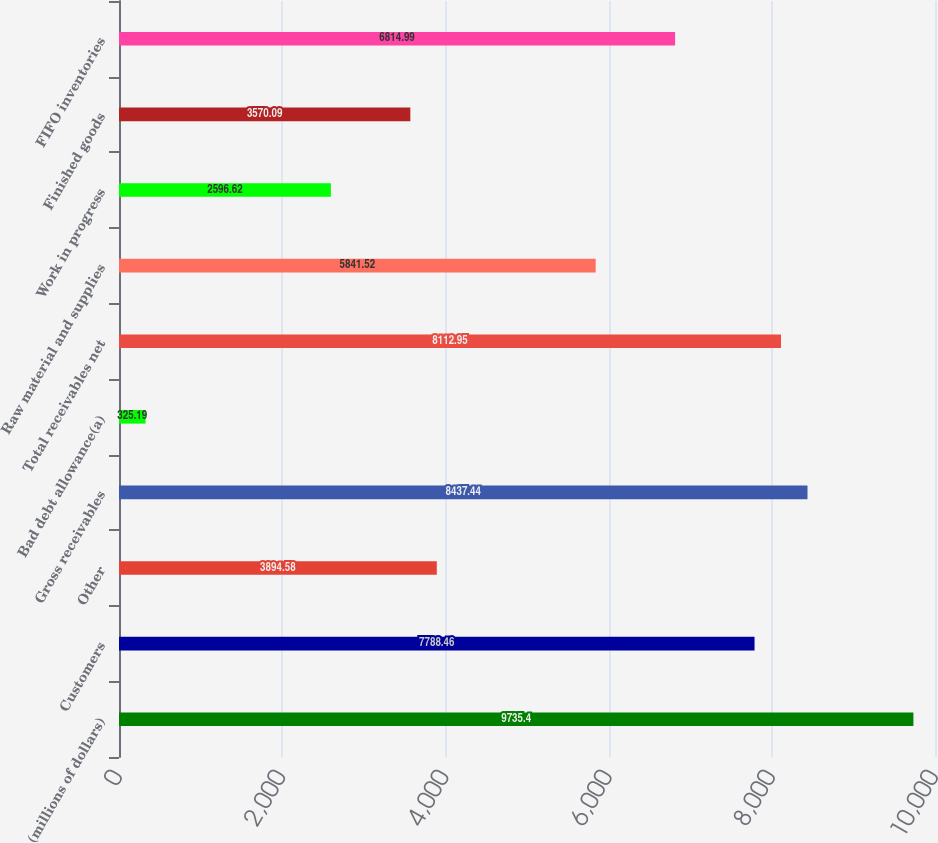Convert chart to OTSL. <chart><loc_0><loc_0><loc_500><loc_500><bar_chart><fcel>(millions of dollars)<fcel>Customers<fcel>Other<fcel>Gross receivables<fcel>Bad debt allowance(a)<fcel>Total receivables net<fcel>Raw material and supplies<fcel>Work in progress<fcel>Finished goods<fcel>FIFO inventories<nl><fcel>9735.4<fcel>7788.46<fcel>3894.58<fcel>8437.44<fcel>325.19<fcel>8112.95<fcel>5841.52<fcel>2596.62<fcel>3570.09<fcel>6814.99<nl></chart> 